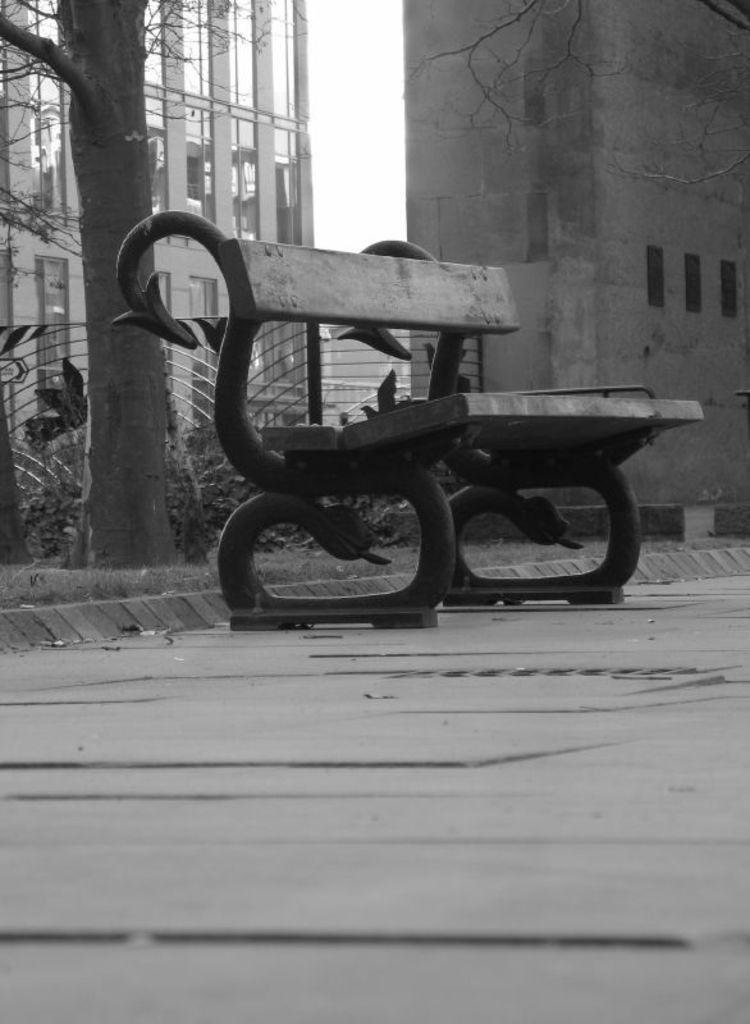What type of seating is present in the image? There is a bench in the image. What can be seen in the distance behind the bench? There are trees and buildings in the background of the image. What is visible in the sky in the image? The sky is visible in the background of the image. What is the color scheme of the image? The image is in black and white. What type of dish is the cook preparing in the image? There is no cook or dish preparation present in the image. How many leaves are visible on the trees in the image? The image is in black and white, so it is not possible to determine the number of leaves on the trees. 